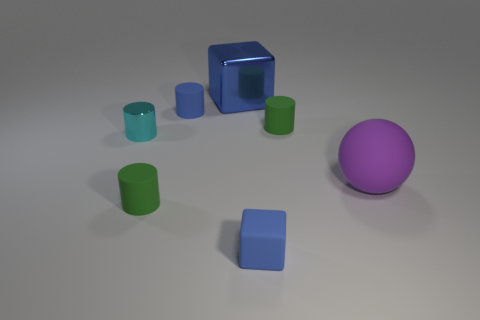What material is the tiny cylinder that is the same color as the metallic block?
Ensure brevity in your answer.  Rubber. Is there any other thing that is the same shape as the big purple matte thing?
Make the answer very short. No. The metal object in front of the green rubber cylinder to the right of the tiny blue matte object that is behind the big purple matte object is what shape?
Provide a succinct answer. Cylinder. Are there fewer big things that are to the right of the matte cube than objects that are on the right side of the big blue metallic block?
Keep it short and to the point. Yes. Are there any matte spheres of the same color as the rubber cube?
Make the answer very short. No. Are the big purple object and the green thing behind the big ball made of the same material?
Your response must be concise. Yes. Is there a green matte cylinder that is to the left of the small blue thing in front of the large purple sphere?
Provide a short and direct response. Yes. There is a tiny cylinder that is both behind the big purple object and to the left of the blue cylinder; what color is it?
Offer a very short reply. Cyan. The sphere is what size?
Your answer should be very brief. Large. What number of matte things are the same size as the cyan metallic cylinder?
Your answer should be very brief. 4. 